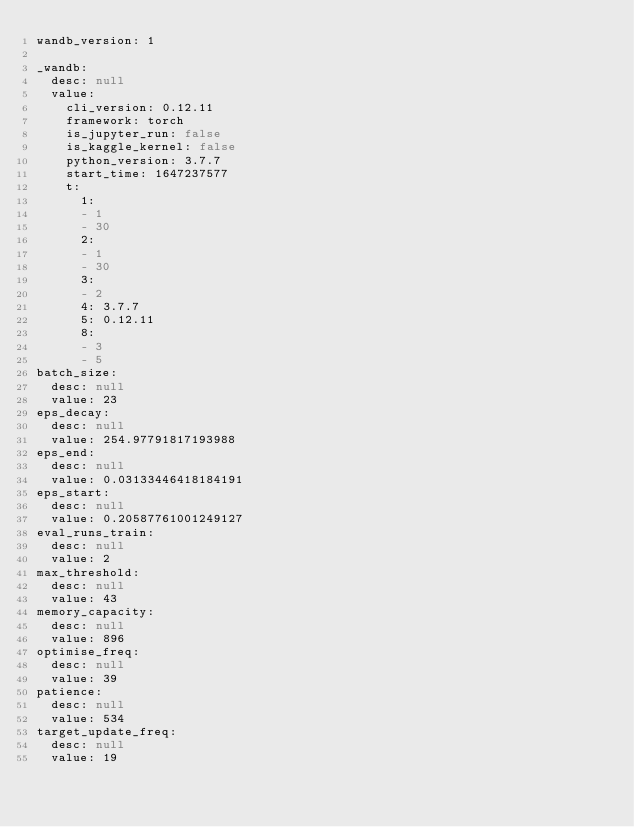<code> <loc_0><loc_0><loc_500><loc_500><_YAML_>wandb_version: 1

_wandb:
  desc: null
  value:
    cli_version: 0.12.11
    framework: torch
    is_jupyter_run: false
    is_kaggle_kernel: false
    python_version: 3.7.7
    start_time: 1647237577
    t:
      1:
      - 1
      - 30
      2:
      - 1
      - 30
      3:
      - 2
      4: 3.7.7
      5: 0.12.11
      8:
      - 3
      - 5
batch_size:
  desc: null
  value: 23
eps_decay:
  desc: null
  value: 254.97791817193988
eps_end:
  desc: null
  value: 0.03133446418184191
eps_start:
  desc: null
  value: 0.20587761001249127
eval_runs_train:
  desc: null
  value: 2
max_threshold:
  desc: null
  value: 43
memory_capacity:
  desc: null
  value: 896
optimise_freq:
  desc: null
  value: 39
patience:
  desc: null
  value: 534
target_update_freq:
  desc: null
  value: 19
</code> 